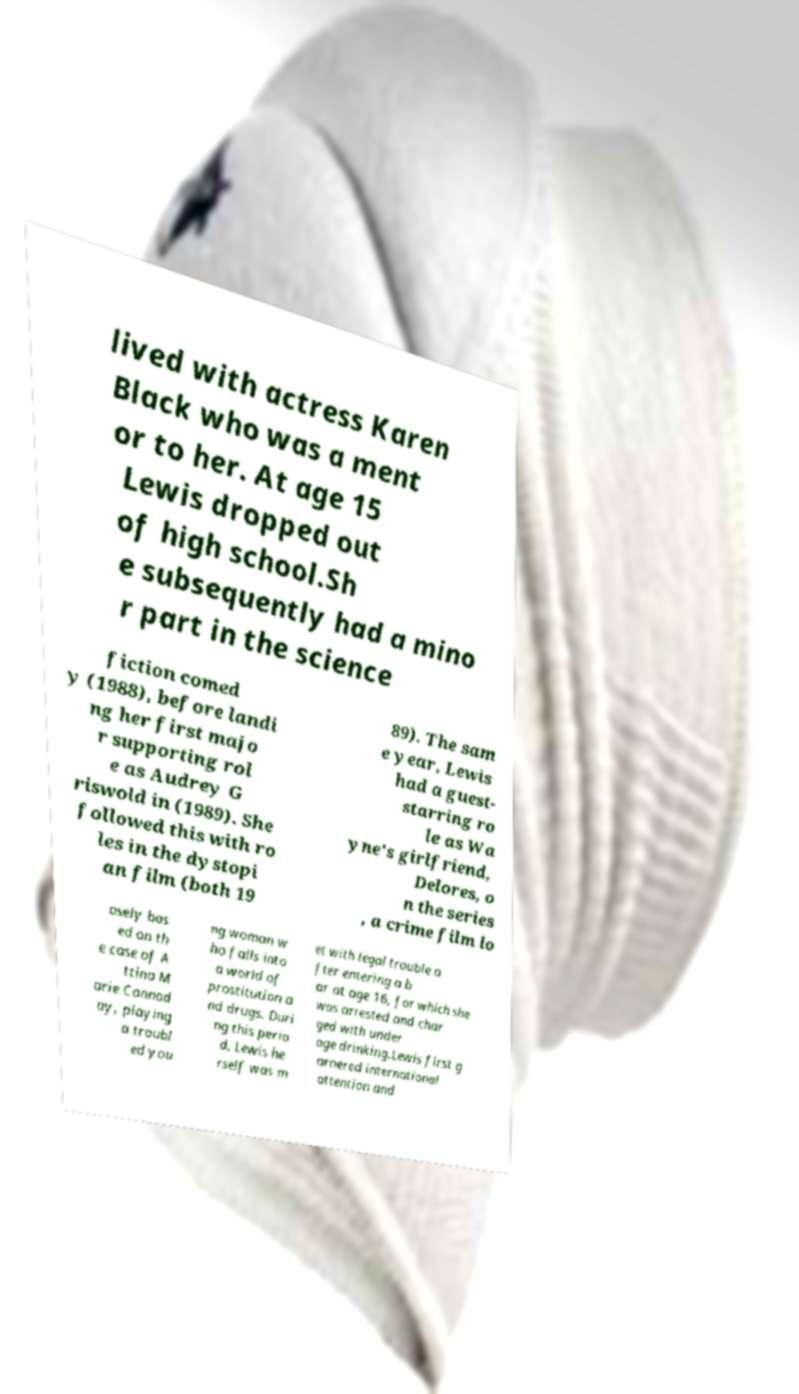Could you extract and type out the text from this image? lived with actress Karen Black who was a ment or to her. At age 15 Lewis dropped out of high school.Sh e subsequently had a mino r part in the science fiction comed y (1988), before landi ng her first majo r supporting rol e as Audrey G riswold in (1989). She followed this with ro les in the dystopi an film (both 19 89). The sam e year, Lewis had a guest- starring ro le as Wa yne's girlfriend, Delores, o n the series , a crime film lo osely bas ed on th e case of A ttina M arie Cannad ay, playing a troubl ed you ng woman w ho falls into a world of prostitution a nd drugs. Duri ng this perio d, Lewis he rself was m et with legal trouble a fter entering a b ar at age 16, for which she was arrested and char ged with under age drinking.Lewis first g arnered international attention and 